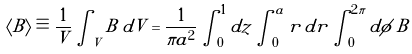<formula> <loc_0><loc_0><loc_500><loc_500>\langle B \rangle \equiv \frac { 1 } { V } \int _ { V } B \, d V = \frac { 1 } { \pi a ^ { 2 } } \int ^ { 1 } _ { 0 } d z \int ^ { a } _ { 0 } r \, d r \int ^ { 2 \pi } _ { 0 } d \phi \, B</formula> 